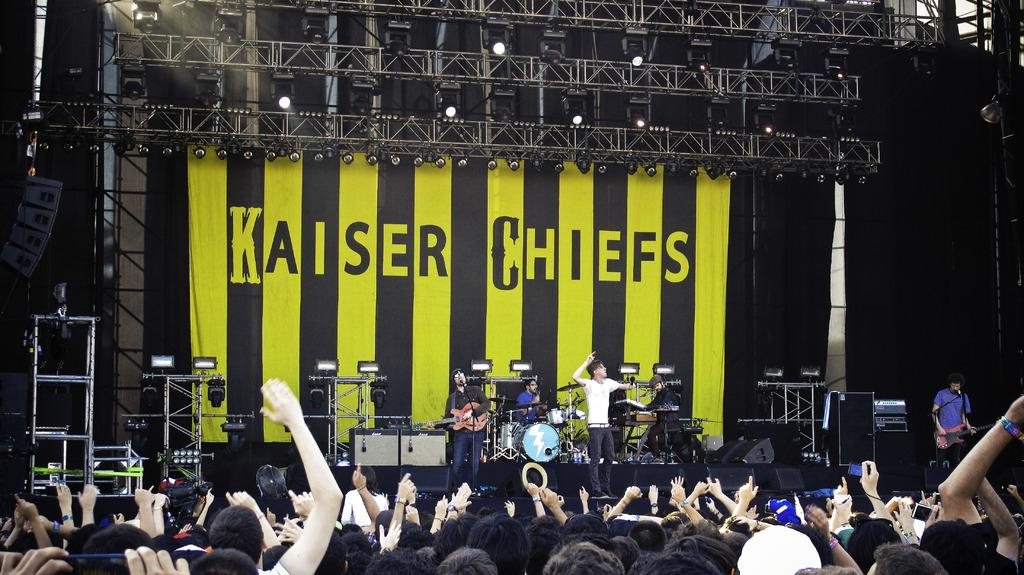What are the persons in the image doing? The persons in the image are playing musical instruments. What can be seen in the image that provides illumination? There are lights visible in the image. What is used to amplify the sound in the image? There are speakers present in the image. How many people are in the image? There is a crowd in the image, which suggests there are multiple people present. What is visible in the background of the image? There is a banner in the background of the image. What type of produce can be seen being harvested by the donkey in the image? There is no donkey or produce present in the image; it features persons playing musical instruments. How does the sail affect the performance of the musicians in the image? There is no sail present in the image; it only features a crowd, lights, speakers, and a banner. 